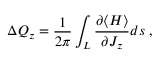<formula> <loc_0><loc_0><loc_500><loc_500>\Delta Q _ { z } = \frac { 1 } { 2 \pi } \int _ { L } \frac { \partial \langle H \rangle } { \partial J _ { z } } d s \, ,</formula> 